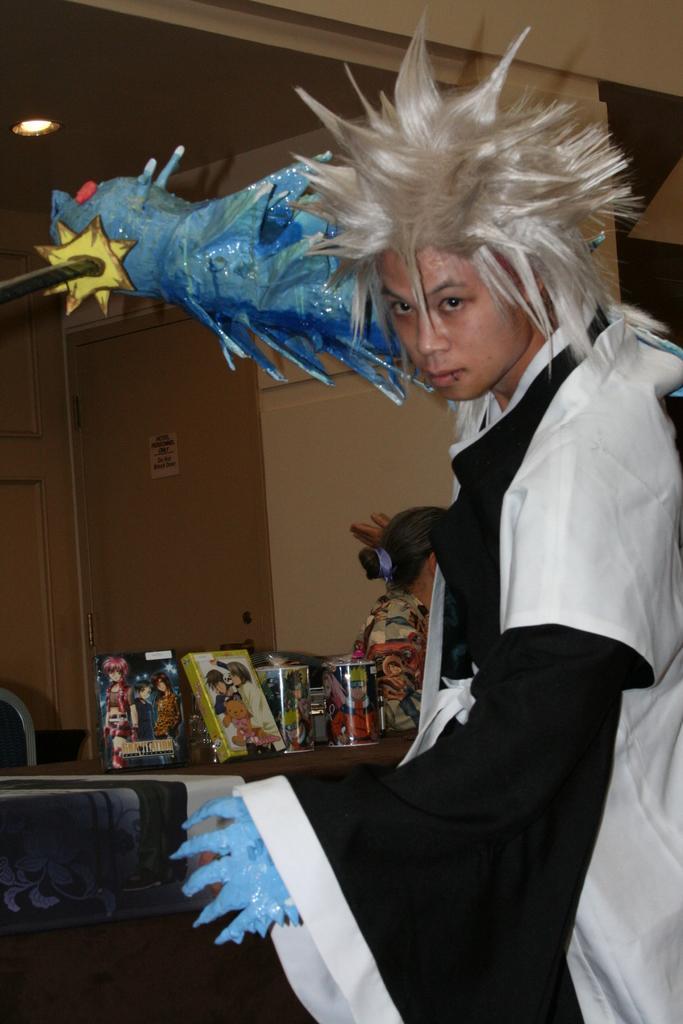Can you describe this image briefly? In this picture we can see a person in the fancy and the person is holding an object. Behind the person there is another person is sitting and some objects on the table. Behind the table there is a chair and a wall with a door. 